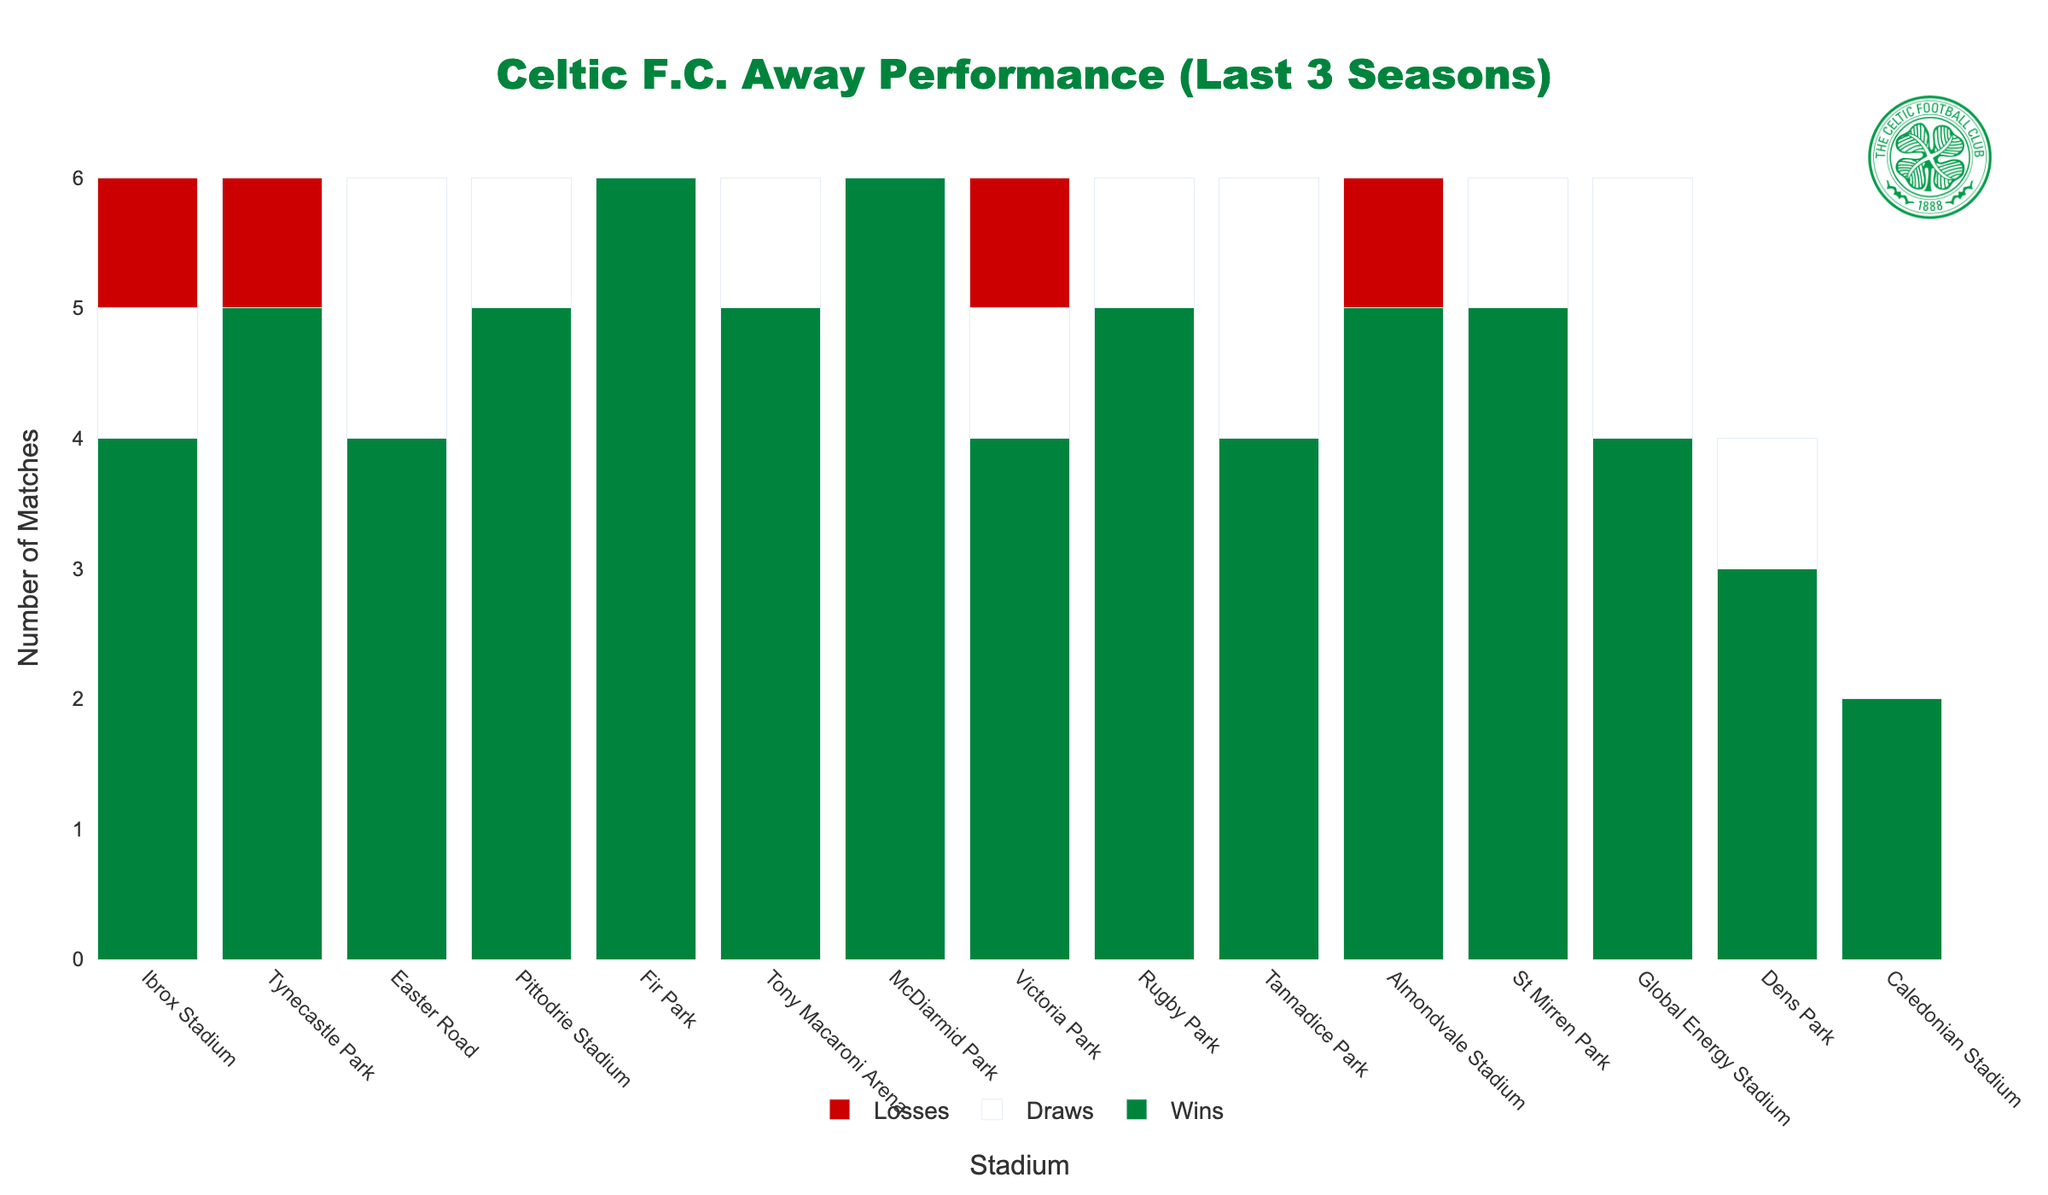Which stadium has the highest number of wins for Celtic F.C. in away matches over the last 3 seasons? To find the stadium with the highest number of wins, we can visually inspect the green bars representing wins in each stadium. McDiarmid Park and Fir Park have the tallest green bars with 6 wins each.
Answer: McDiarmid Park and Fir Park What is the total number of matches played at Ibrox Stadium? To calculate the total number of matches at Ibrox Stadium, sum the values of wins, draws, and losses: 4 (Wins) + 1 (Draw) + 1 (Loss) = 6.
Answer: 6 How many more wins does Celtic F.C. have at Pittodrie Stadium compared to Victoria Park? To find the difference, subtract the number of wins at Victoria Park from the number of wins at Pittodrie Stadium: 5 (Pittodrie Stadium) - 4 (Victoria Park) = 1.
Answer: 1 Which stadiums have recorded exactly 1 draw in Celtic’s away matches over the last 3 seasons? To find the stadiums with exactly 1 draw, visually inspect the white bars representing draws. The stadiums with one draw are Ibrox Stadium, Pittodrie Stadium, Tony Macaroni Arena, Rugby Park, St Mirren Park, and Dens Park.
Answer: Ibrox Stadium, Pittodrie Stadium, Tony Macaroni Arena, Rugby Park, St Mirren Park, and Dens Park What is the combined number of wins and draws for Celtic F.C. at Easter Road? Add the number of wins and draws at Easter Road: 4 (Wins) + 2 (Draws) = 6.
Answer: 6 Which stadium has the tallest red bar and what does this represent? The stadium with the tallest red bar is Ibrox Stadium indicating that it has the highest number of losses. Ibrox's red bar height represents 1 loss.
Answer: Ibrox Stadium, 1 loss How many total away matches has Celtic F.C. played at Fir Park? Sum the wins, draws, and losses at Fir Park: 6 (Wins) + 0 (Draws) + 0 (Losses) = 6.
Answer: 6 Which two stadiums have an identical record, including the number of wins, draws, and losses? Visually inspect the bars for identical heights in all categories (Wins, Draws, and Losses). Easter Road and Tannadice Park both have 4 Wins and 2 Draws with 0 Losses.
Answer: Easter Road and Tannadice Park What is the total number of draws across all stadiums? Sum the draws for each stadium: 1+0+2+1+0+1+0+1+1+2+0+1+2+1+0 = 13.
Answer: 13 